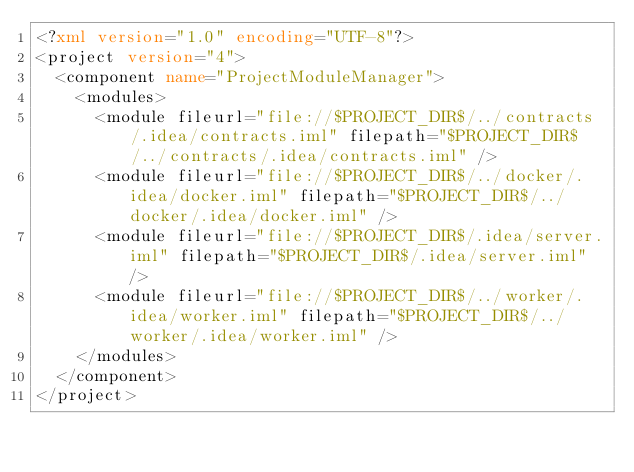<code> <loc_0><loc_0><loc_500><loc_500><_XML_><?xml version="1.0" encoding="UTF-8"?>
<project version="4">
  <component name="ProjectModuleManager">
    <modules>
      <module fileurl="file://$PROJECT_DIR$/../contracts/.idea/contracts.iml" filepath="$PROJECT_DIR$/../contracts/.idea/contracts.iml" />
      <module fileurl="file://$PROJECT_DIR$/../docker/.idea/docker.iml" filepath="$PROJECT_DIR$/../docker/.idea/docker.iml" />
      <module fileurl="file://$PROJECT_DIR$/.idea/server.iml" filepath="$PROJECT_DIR$/.idea/server.iml" />
      <module fileurl="file://$PROJECT_DIR$/../worker/.idea/worker.iml" filepath="$PROJECT_DIR$/../worker/.idea/worker.iml" />
    </modules>
  </component>
</project></code> 